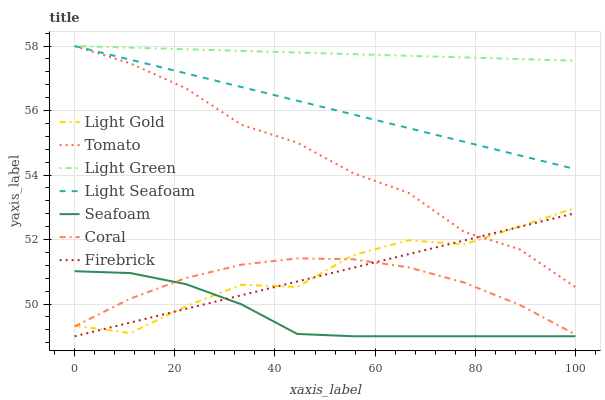Does Seafoam have the minimum area under the curve?
Answer yes or no. Yes. Does Light Green have the maximum area under the curve?
Answer yes or no. Yes. Does Coral have the minimum area under the curve?
Answer yes or no. No. Does Coral have the maximum area under the curve?
Answer yes or no. No. Is Light Green the smoothest?
Answer yes or no. Yes. Is Light Gold the roughest?
Answer yes or no. Yes. Is Coral the smoothest?
Answer yes or no. No. Is Coral the roughest?
Answer yes or no. No. Does Seafoam have the lowest value?
Answer yes or no. Yes. Does Coral have the lowest value?
Answer yes or no. No. Does Light Seafoam have the highest value?
Answer yes or no. Yes. Does Coral have the highest value?
Answer yes or no. No. Is Seafoam less than Light Green?
Answer yes or no. Yes. Is Light Green greater than Seafoam?
Answer yes or no. Yes. Does Coral intersect Light Gold?
Answer yes or no. Yes. Is Coral less than Light Gold?
Answer yes or no. No. Is Coral greater than Light Gold?
Answer yes or no. No. Does Seafoam intersect Light Green?
Answer yes or no. No. 